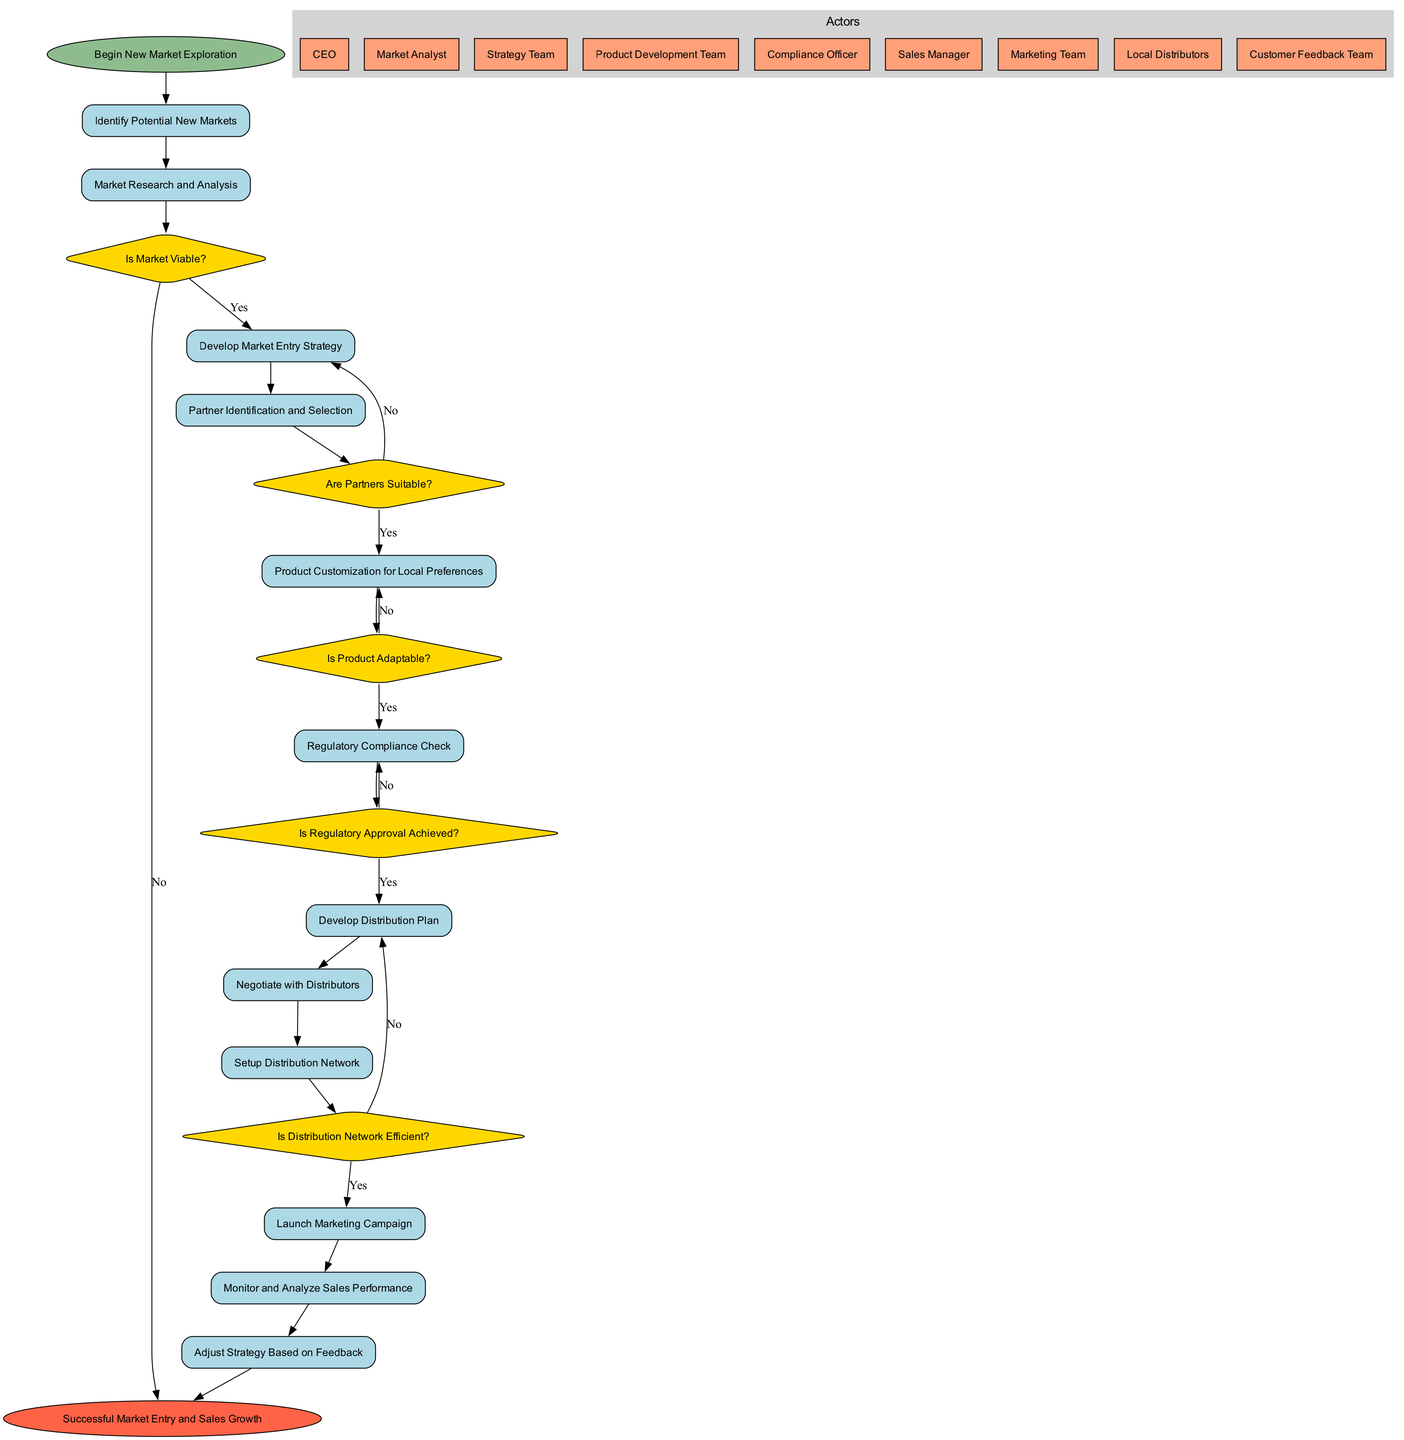What is the starting point of the workflow? The starting point of the workflow is clearly labeled in the diagram as "Begin New Market Exploration." This is the node from which all activities are initiated.
Answer: Begin New Market Exploration What decision follows Market Research and Analysis? The decision that follows the "Market Research and Analysis" activity is labeled as "Is Market Viable?". This decision point directly assesses the findings from the market research.
Answer: Is Market Viable? How many activities are there in the diagram? The diagram includes a total of twelve activities. These are sequential steps depicted in rectangular nodes, and counting them confirms the total number.
Answer: 12 Which actor is responsible for ensuring regulatory compliance? The actor responsible for ensuring regulatory compliance in the diagram is labeled as "Compliance Officer". This actor is essential for navigating regulatory checks within the workflow.
Answer: Compliance Officer What happens if regulatory approval is not achieved? If regulatory approval is not achieved, the workflow redirects back to "Product Customization for Local Preferences". This indicates a need for further refinement before proceeding.
Answer: Product Customization for Local Preferences What is the end point of the workflow? The end point of the workflow is labeled as "Successful Market Entry and Sales Growth." This indicates the ultimate goal of the entire process illustrated in the diagram.
Answer: Successful Market Entry and Sales Growth Which decision point assesses the efficiency of the distribution network? The decision point that assesses the efficiency of the distribution network is labeled "Is Distribution Network Efficient?". This points to ensuring that the distribution strategy is viable before launching.
Answer: Is Distribution Network Efficient? What activity directly follows the decision on product adaptability? The activity that directly follows the decision on product adaptability ("Is Product Adaptable?") is "Regulatory Compliance Check." This indicates a sequential process following this assessment.
Answer: Regulatory Compliance Check How many decision points are in the workflow? There are five decision points in the workflow. Each is represented as a diamond-shaped node and is crucial for navigating various paths in the process.
Answer: 5 